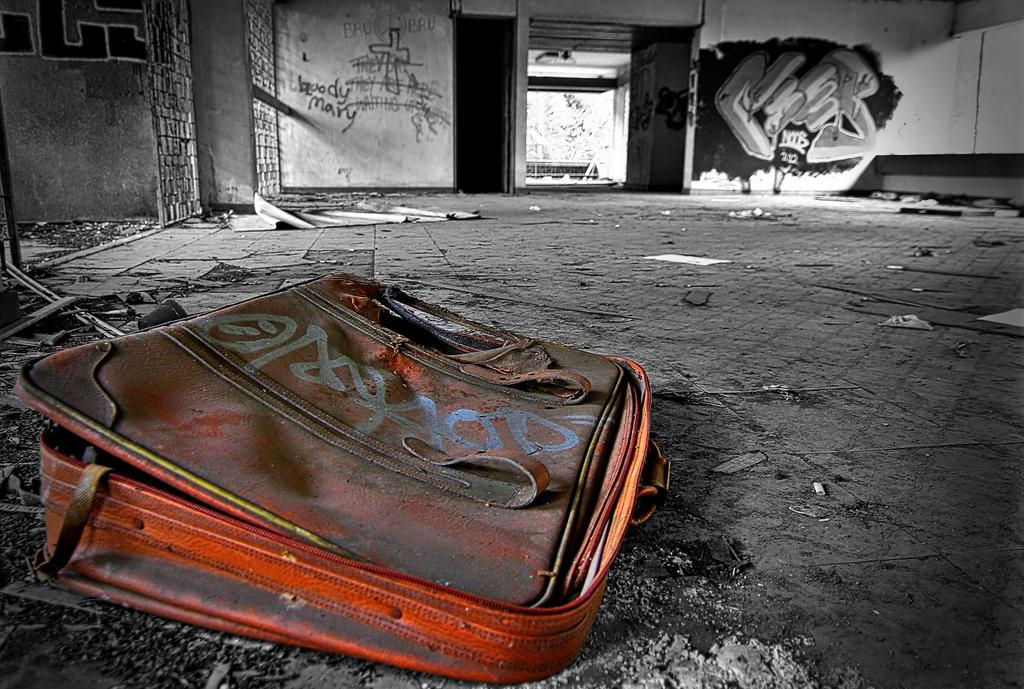What is inside the bag that is visible in the image? There is a bag with dust in the image. What can be seen in the background of the image? There is a gate, a wall, paintings, a tree, and a shed in the background of the image. What else is present in the background of the image? There are papers in the background of the image. What color are the eyes of the person holding the umbrella in the image? There is no person holding an umbrella in the image; the focus is on the bag with dust and the background elements. 